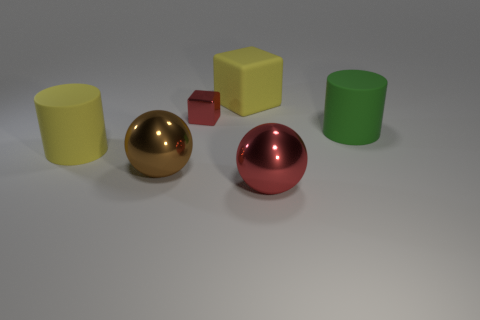Add 4 big yellow rubber objects. How many objects exist? 10 Subtract all balls. How many objects are left? 4 Subtract all yellow rubber things. Subtract all small metal objects. How many objects are left? 3 Add 4 red spheres. How many red spheres are left? 5 Add 5 small red metallic blocks. How many small red metallic blocks exist? 6 Subtract 0 yellow balls. How many objects are left? 6 